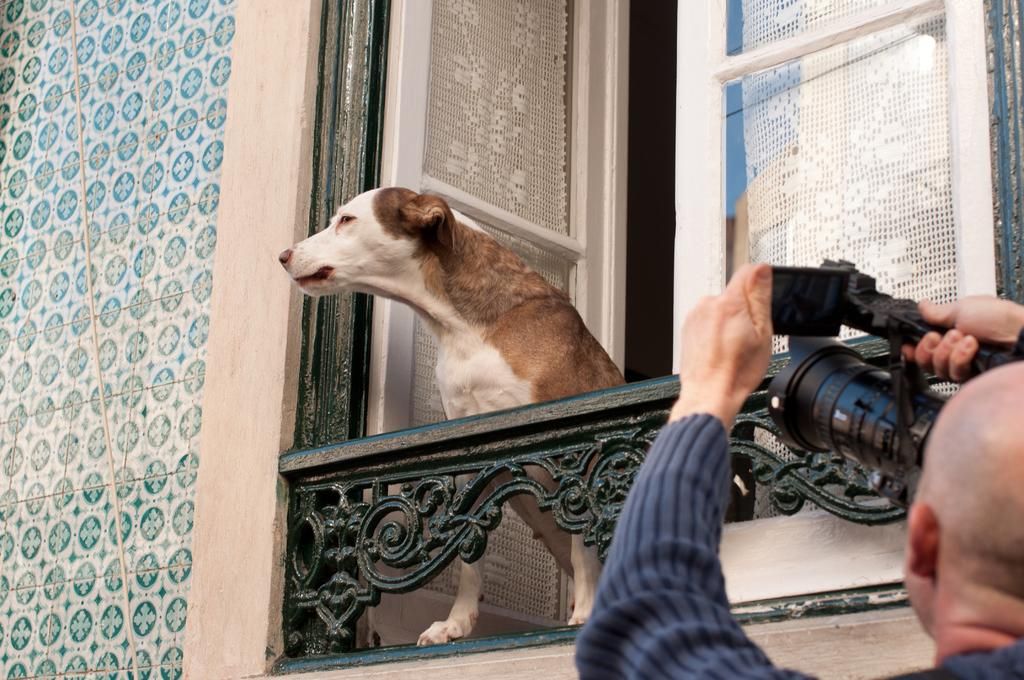What animal can be seen in the image? There is a dog in the image. What is the dog doing in the image? The dog is looking outside through a window. Who else is present in the image? There is a person in the image. What is the person doing in the image? The person is standing in front of the window and holding a camera. What is the person's intention in the image? The person is attempting to capture a photo of the dog. What type of wood is being used for the operation in the image? There is no wood or operation present in the image; it features a dog looking outside through a window and a person attempting to capture a photo of the dog. 